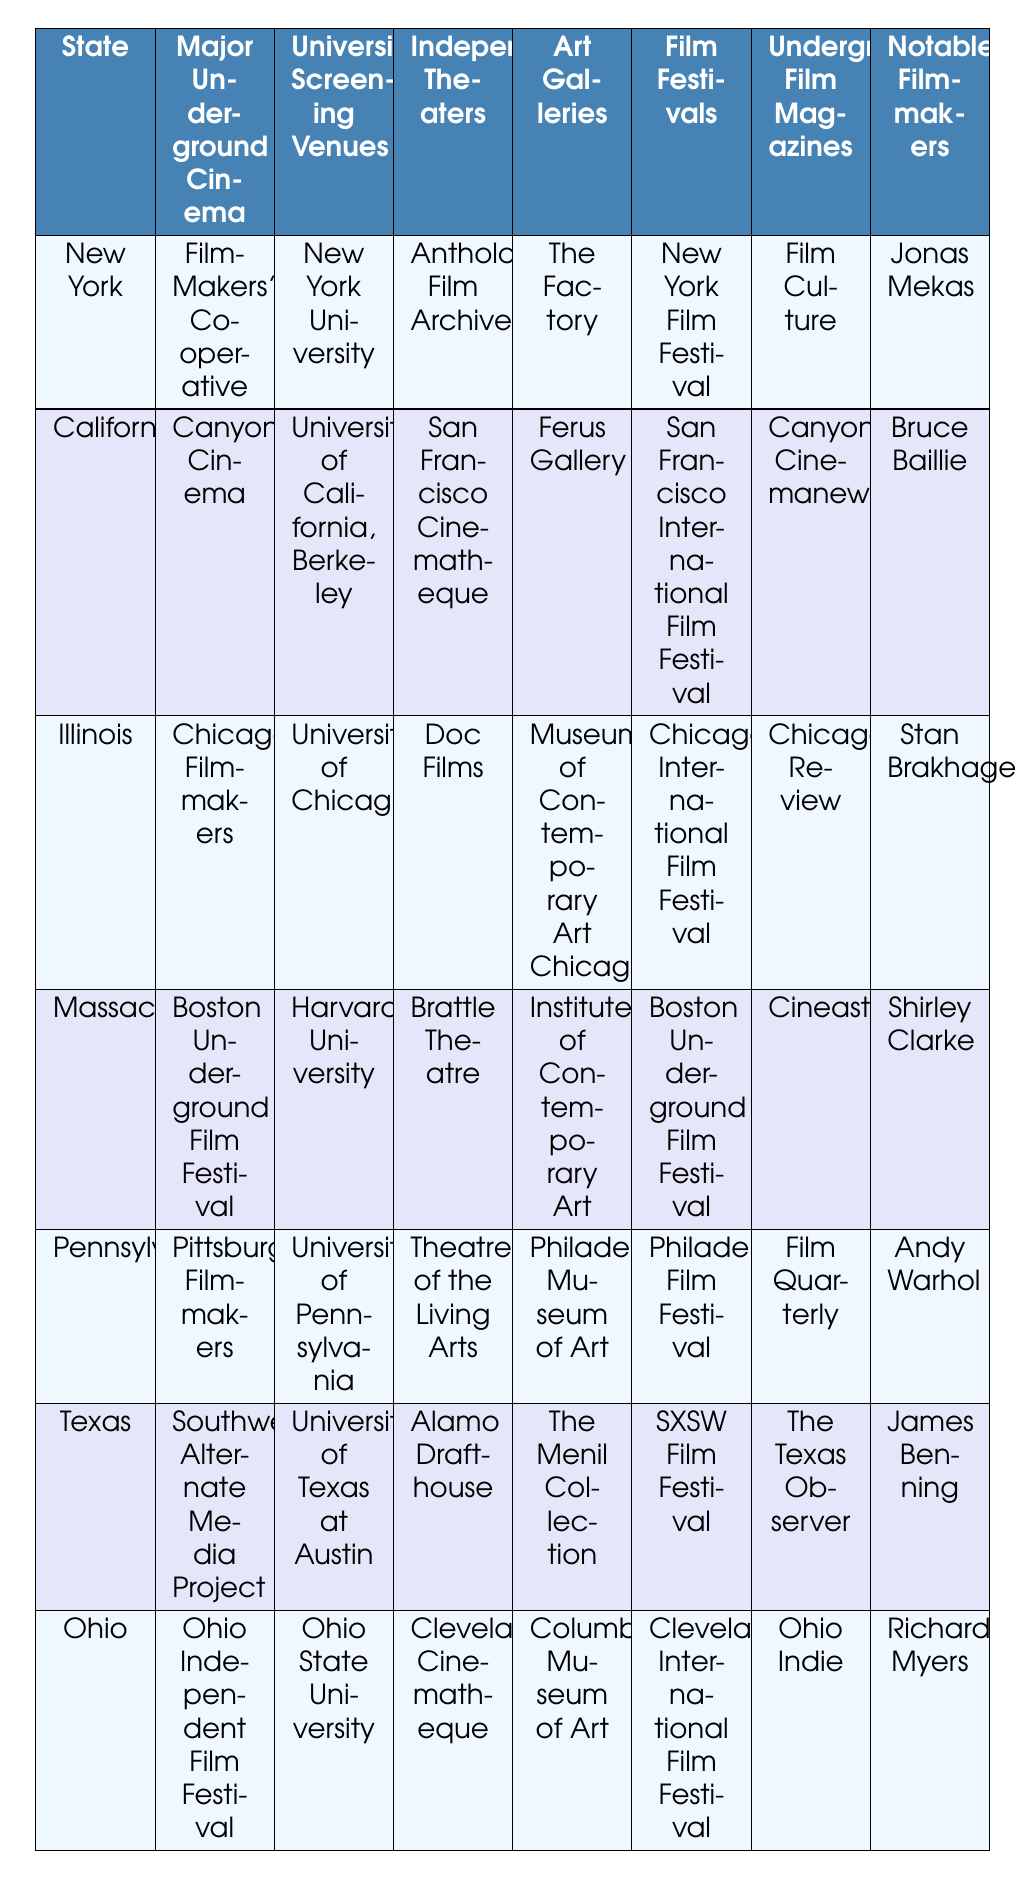What major underground cinema is associated with New York? Referring to the table, the entry in the row for New York under the column "Major Underground Cinema" states "Film-Makers' Cooperative."
Answer: Film-Makers' Cooperative Which state has Canyon Cinema as its major underground cinema? Looking at the table, "Canyon Cinema" is listed under the "Major Underground Cinema" column for California.
Answer: California Name the university screening venue located in Ohio. The row corresponding to Ohio shows "Ohio State University" under the "University Screening Venues" column.
Answer: Ohio State University Is the "Brattle Theatre" listed as an independent theater in Massachusetts? In the table, "Brattle Theatre" is indeed listed under the "Independent Theaters" column for Massachusetts.
Answer: Yes How many states have a specific underground film magazine listed? There are seven entries in the "State" column, and each state has its own magazine listed under the "Underground Film Magazines" column, indicating all states have magazines associated. Thus, there are seven states with a magazine listed.
Answer: 7 Which state has the Pittsburgh Filmmakers organization? The entry for Pennsylvania under the "Major Underground Cinema" column indicates "Pittsburgh Filmmakers" is associated with Pennsylvania.
Answer: Pennsylvania Identify the notable filmmaker associated with Texas. Under the "Notable Filmmakers" column for Texas, the name listed is "James Benning."
Answer: James Benning How many independent theaters are listed for the state of Illinois? The table indicates a single entry under the "Independent Theaters" column for Illinois, which is "Doc Films." Thus, there is one independent theater.
Answer: 1 Which art gallery is associated with underground films in California? The entry for California under the "Art Galleries" column indicates "Ferus Gallery" is associated with underground films.
Answer: Ferus Gallery What is the relationship between the Boston Underground Film Festival and Massachusetts? The "Boston Underground Film Festival" is listed as both the "Major Underground Cinema" and the "Film Festivals" for Massachusetts, indicating its prominence in underground film in that state.
Answer: Both categories are associated with Massachusetts What film festival is unique to New York from the listed states? The "New York Film Festival" is listed under the "Film Festivals" column for New York and is not mentioned as being in any other state, making it unique to New York.
Answer: New York Film Festival How many states have their independent theaters listed? Each of the seven states has one independent theater listed, meaning all seven states have independent theaters presented.
Answer: 7 